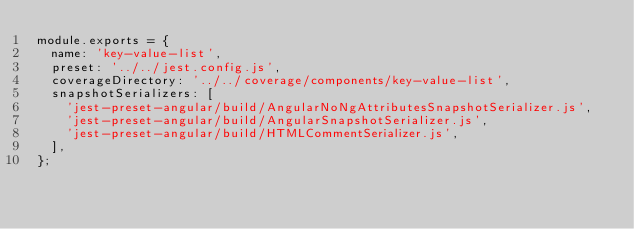Convert code to text. <code><loc_0><loc_0><loc_500><loc_500><_JavaScript_>module.exports = {
  name: 'key-value-list',
  preset: '../../jest.config.js',
  coverageDirectory: '../../coverage/components/key-value-list',
  snapshotSerializers: [
    'jest-preset-angular/build/AngularNoNgAttributesSnapshotSerializer.js',
    'jest-preset-angular/build/AngularSnapshotSerializer.js',
    'jest-preset-angular/build/HTMLCommentSerializer.js',
  ],
};
</code> 